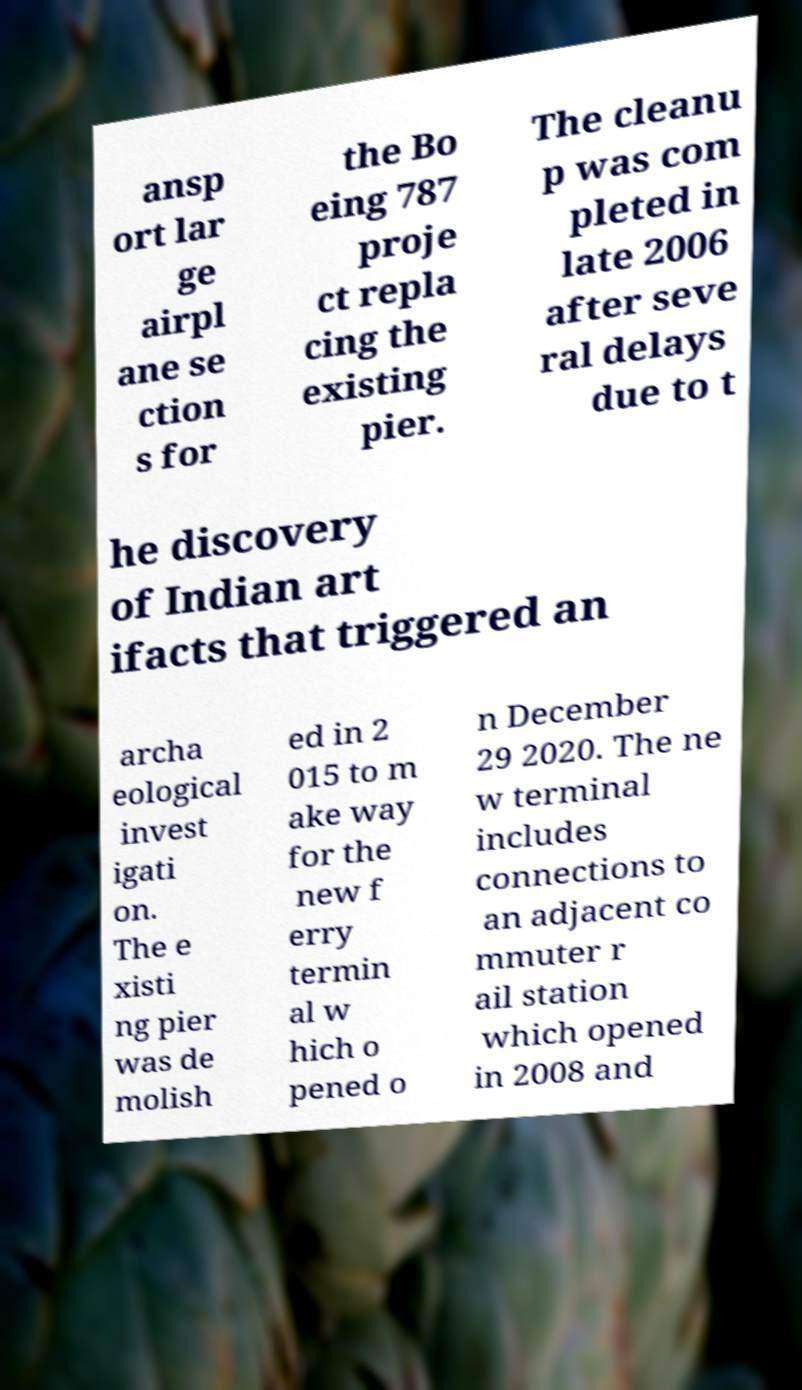Can you accurately transcribe the text from the provided image for me? ansp ort lar ge airpl ane se ction s for the Bo eing 787 proje ct repla cing the existing pier. The cleanu p was com pleted in late 2006 after seve ral delays due to t he discovery of Indian art ifacts that triggered an archa eological invest igati on. The e xisti ng pier was de molish ed in 2 015 to m ake way for the new f erry termin al w hich o pened o n December 29 2020. The ne w terminal includes connections to an adjacent co mmuter r ail station which opened in 2008 and 